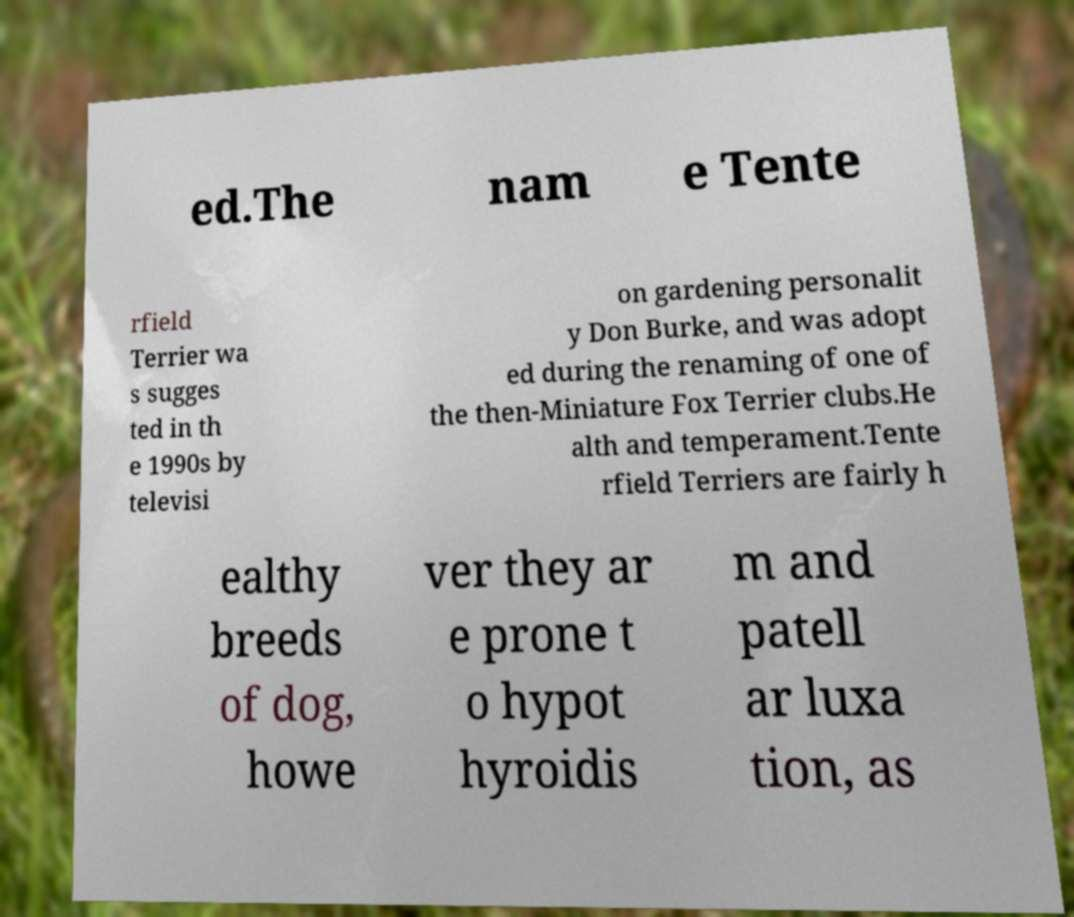Please identify and transcribe the text found in this image. ed.The nam e Tente rfield Terrier wa s sugges ted in th e 1990s by televisi on gardening personalit y Don Burke, and was adopt ed during the renaming of one of the then-Miniature Fox Terrier clubs.He alth and temperament.Tente rfield Terriers are fairly h ealthy breeds of dog, howe ver they ar e prone t o hypot hyroidis m and patell ar luxa tion, as 